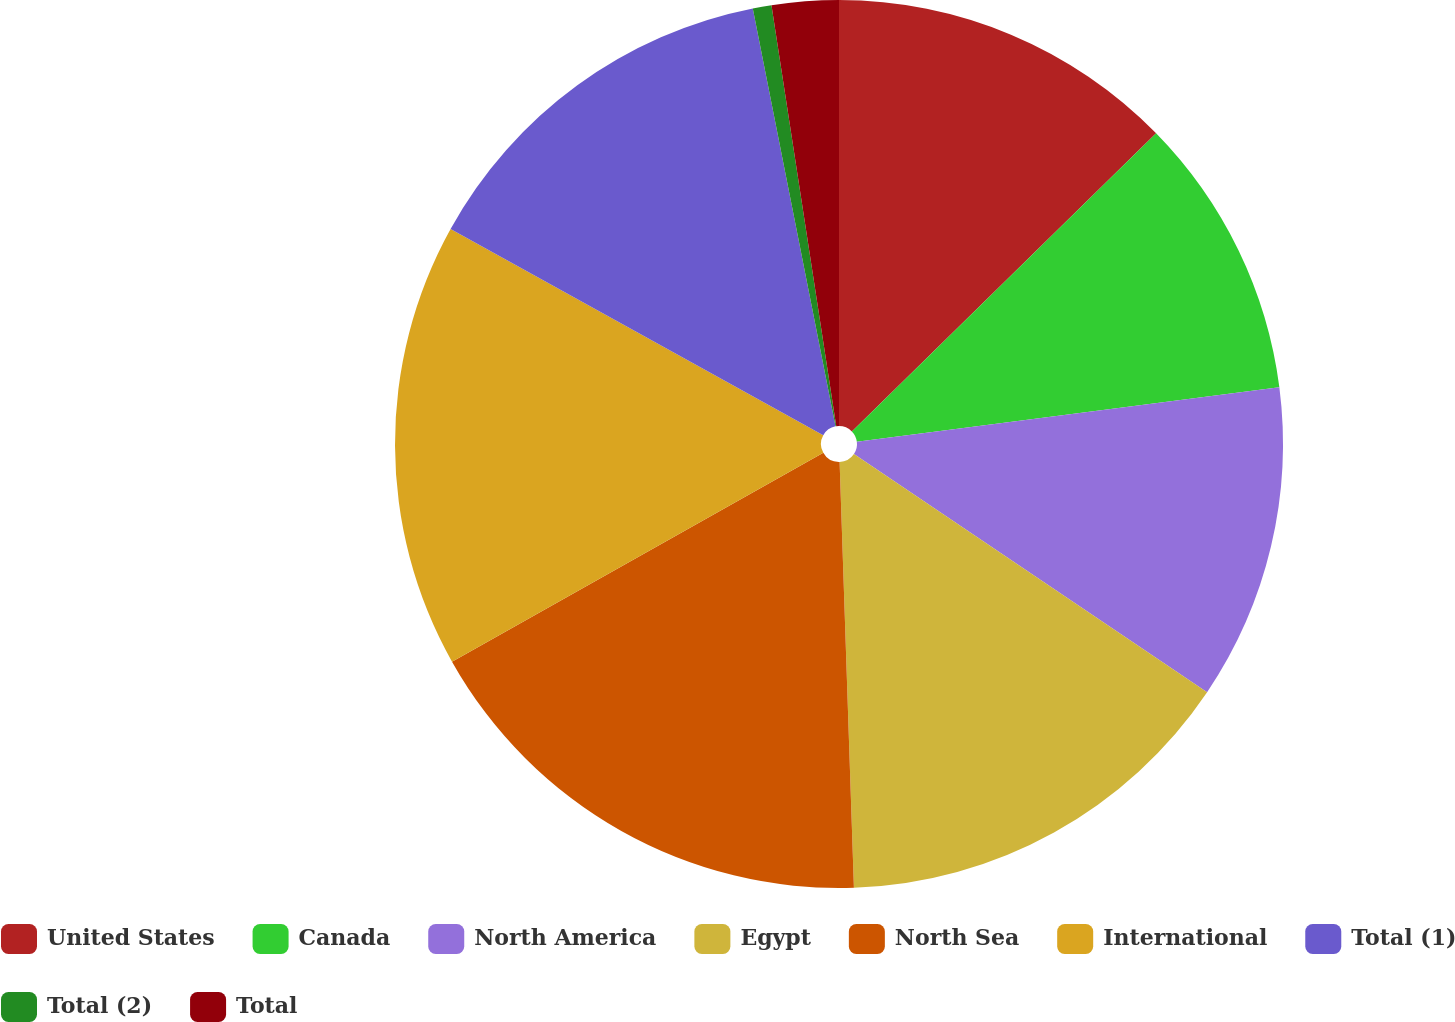<chart> <loc_0><loc_0><loc_500><loc_500><pie_chart><fcel>United States<fcel>Canada<fcel>North America<fcel>Egypt<fcel>North Sea<fcel>International<fcel>Total (1)<fcel>Total (2)<fcel>Total<nl><fcel>12.66%<fcel>10.3%<fcel>11.48%<fcel>15.02%<fcel>17.38%<fcel>16.2%<fcel>13.84%<fcel>0.68%<fcel>2.43%<nl></chart> 